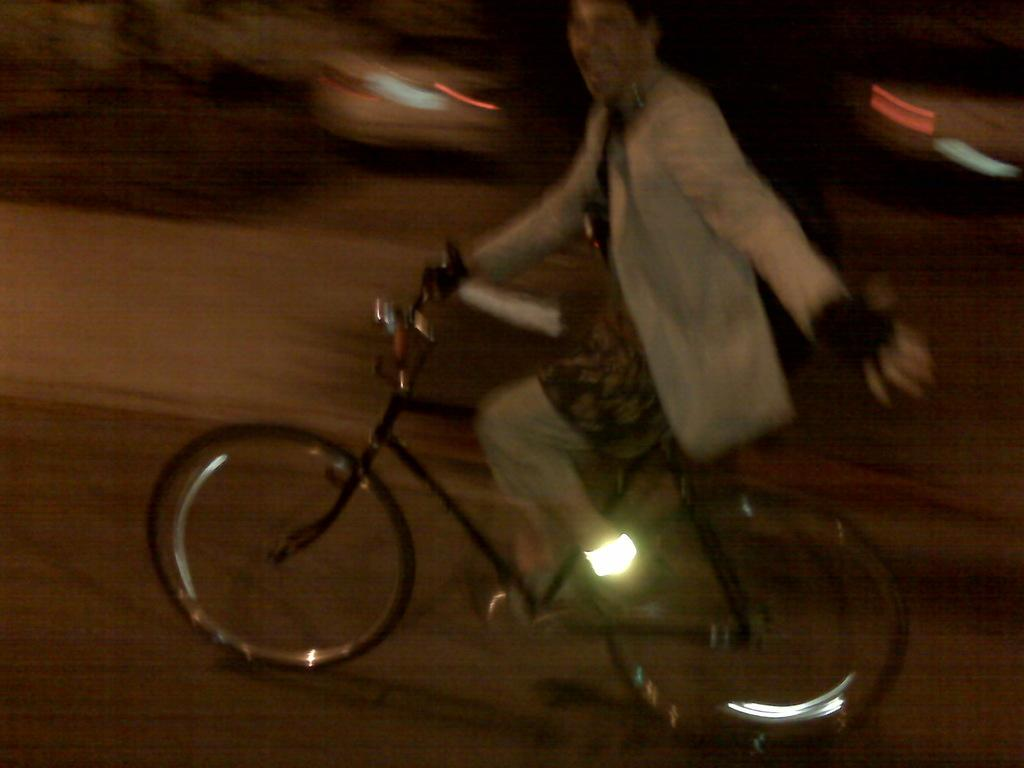What is the main subject of the image? There is a person riding a bicycle in the image. Where is the person riding the bicycle? The person is on the road. What else can be seen in the image besides the person on the bicycle? There are vehicles visible in the image. How would you describe the quality of the image? The image is blurry. What type of lace is being used to decorate the brick in the image? There is no lace or brick present in the image; it features a person riding a bicycle on the road with vehicles visible. 